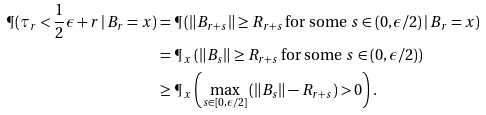<formula> <loc_0><loc_0><loc_500><loc_500>\P ( \tau _ { r } < \frac { 1 } { 2 } \epsilon + r \, | \, B _ { r } = x ) & = \P \left ( \| B _ { r + s } \| \geq R _ { r + s } \, \text {for some $s \in (0,\epsilon/2)$} \, | \, B _ { r } = x \right ) \\ & = \P _ { \, x } \left ( \| B _ { s } \| \geq R _ { r + s } \, \text {for some $s \in (0,\epsilon/2)$} \right ) \\ & \geq \P _ { \, x } \left ( \max _ { s \in [ 0 , \epsilon / 2 ] } \left ( \| B _ { s } \| - R _ { r + s } \right ) > 0 \right ) .</formula> 